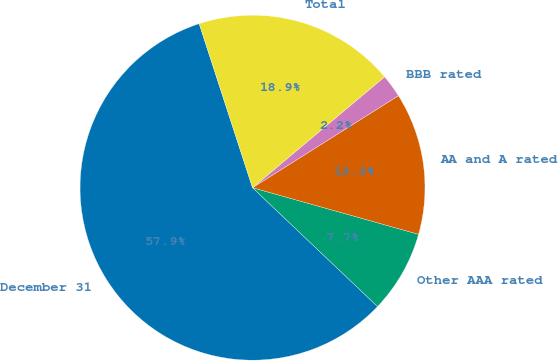<chart> <loc_0><loc_0><loc_500><loc_500><pie_chart><fcel>December 31<fcel>Other AAA rated<fcel>AA and A rated<fcel>BBB rated<fcel>Total<nl><fcel>57.9%<fcel>7.74%<fcel>13.31%<fcel>2.16%<fcel>18.89%<nl></chart> 